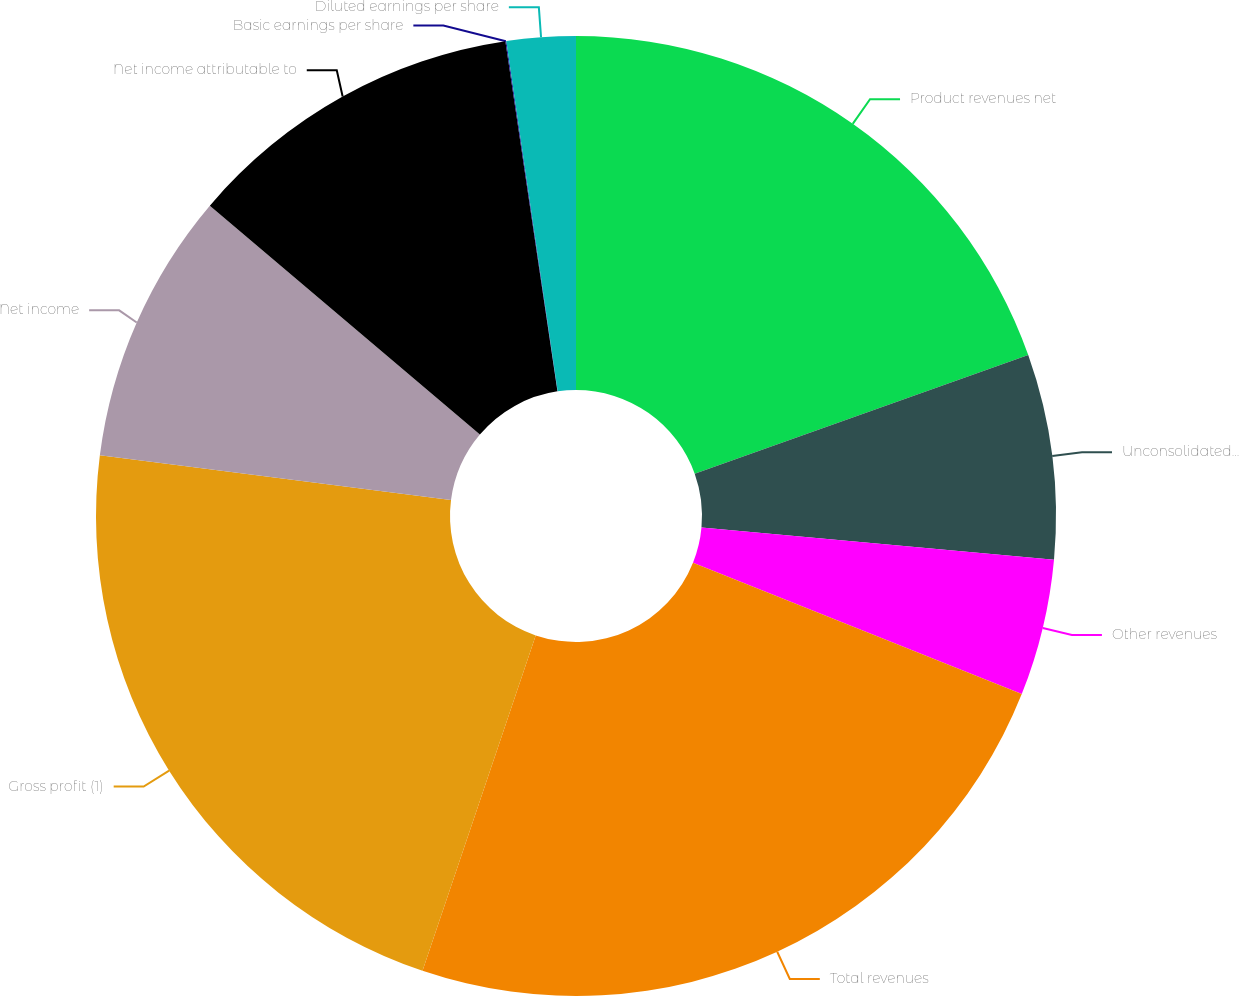<chart> <loc_0><loc_0><loc_500><loc_500><pie_chart><fcel>Product revenues net<fcel>Unconsolidated joint business<fcel>Other revenues<fcel>Total revenues<fcel>Gross profit (1)<fcel>Net income<fcel>Net income attributable to<fcel>Basic earnings per share<fcel>Diluted earnings per share<nl><fcel>19.56%<fcel>6.89%<fcel>4.6%<fcel>24.13%<fcel>21.84%<fcel>9.17%<fcel>11.46%<fcel>0.03%<fcel>2.32%<nl></chart> 